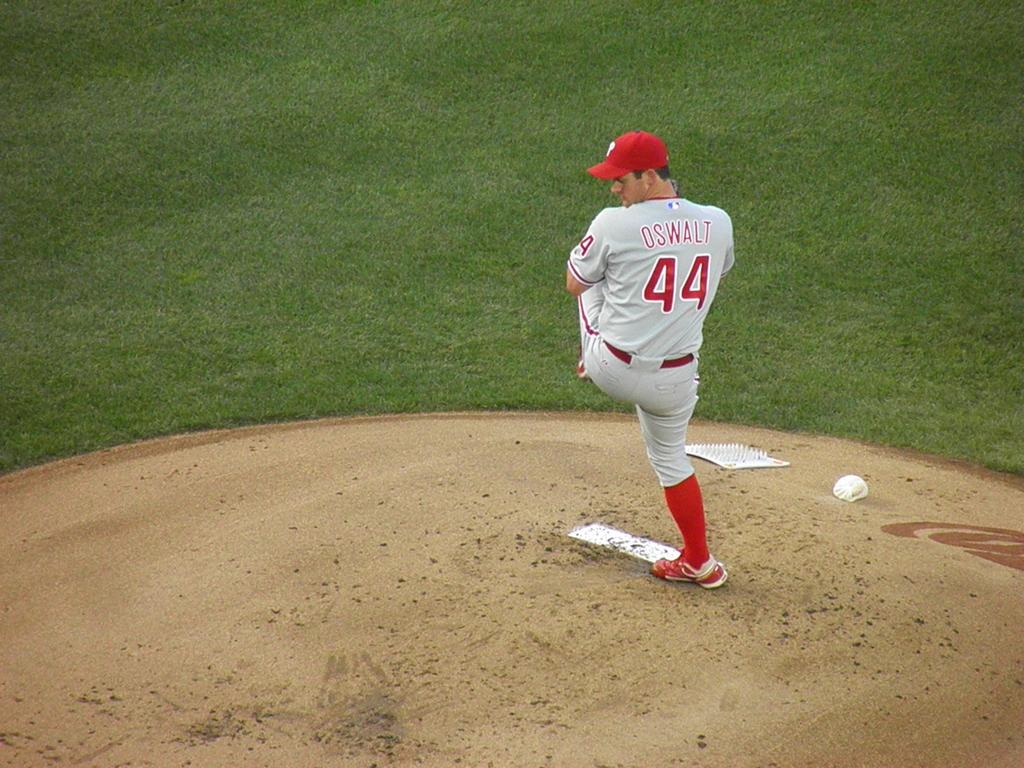<image>
Share a concise interpretation of the image provided. a player with 44 on their jersey on the mound 